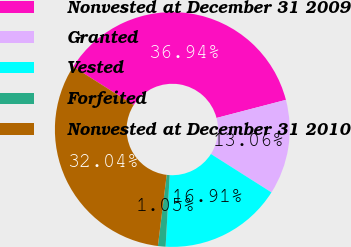Convert chart to OTSL. <chart><loc_0><loc_0><loc_500><loc_500><pie_chart><fcel>Nonvested at December 31 2009<fcel>Granted<fcel>Vested<fcel>Forfeited<fcel>Nonvested at December 31 2010<nl><fcel>36.94%<fcel>13.06%<fcel>16.91%<fcel>1.05%<fcel>32.04%<nl></chart> 